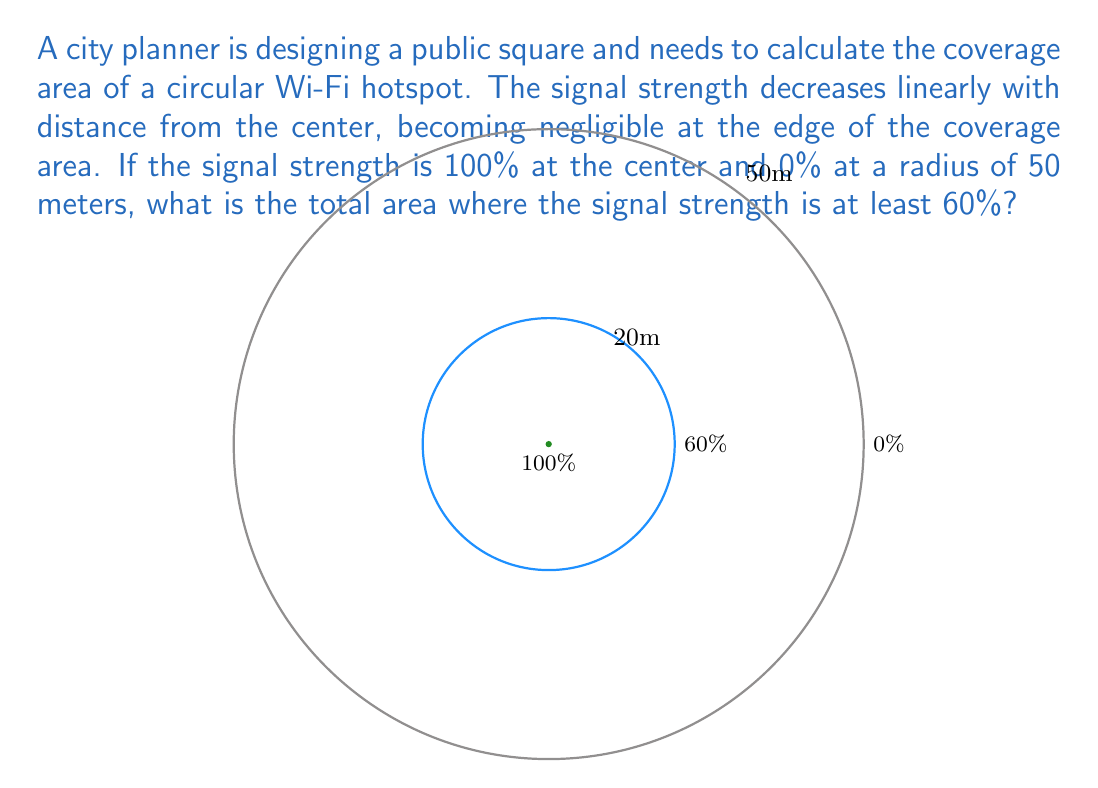Give your solution to this math problem. Let's approach this step-by-step:

1) First, we need to determine the radius at which the signal strength is 60%. Since the strength decreases linearly, we can set up a proportion:

   $\frac{100\% - 60\%}{100\% - 0\%} = \frac{r - 0}{50m - 0}$

   Where $r$ is the radius we're looking for.

2) Simplify:
   
   $\frac{40\%}{100\%} = \frac{r}{50m}$

3) Solve for $r$:
   
   $r = 50m \cdot \frac{40}{100} = 20m$

4) Now that we know the radius, we can calculate the area using the formula for the area of a circle:

   $A = \pi r^2$

5) Plugging in our radius:

   $A = \pi (20m)^2 = 400\pi m^2$

6) Simplify:

   $A = 1256.64 m^2$ (rounded to two decimal places)

Thus, the area where the signal strength is at least 60% is approximately 1256.64 square meters.
Answer: $1256.64 m^2$ 